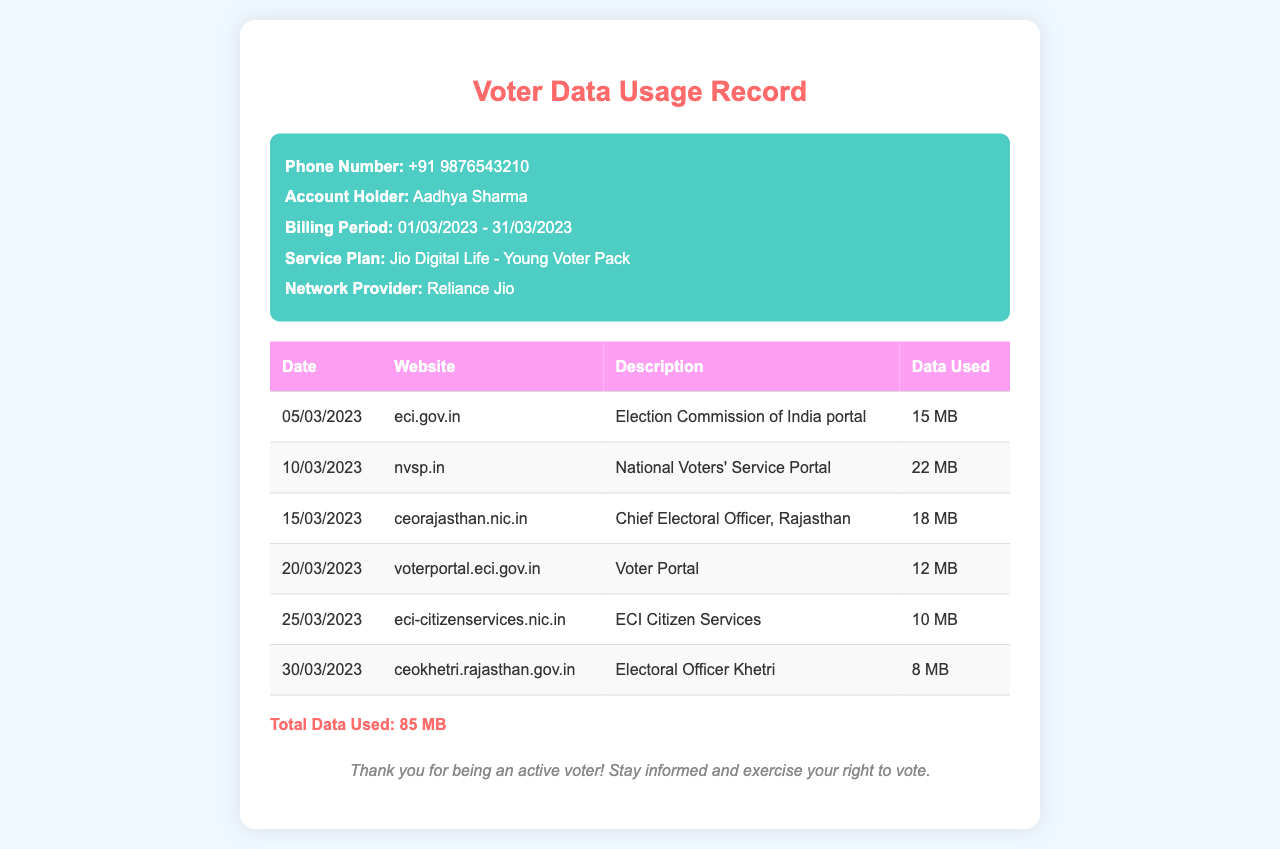what is the phone number listed? The phone number is provided in the header section of the document as a point of reference for the account holder.
Answer: +91 9876543210 what is the total data used during the billing period? The total data used is calculated from the individual data usage provided for each website in the table.
Answer: 85 MB what is the billing period for this record? The billing period indicates the timeframe during which the recorded data usage was measured.
Answer: 01/03/2023 - 31/03/2023 how many megabytes were used on the National Voters' Service Portal? This is found in the corresponding row for the National Voters' Service Portal in the table.
Answer: 22 MB which website had the lowest data usage? The question examines the data usage across all listed websites to find the minimum amount used.
Answer: ceokhetri.rajasthan.gov.in who is the account holder? This is specified in the header section of the document, identifying the individual associated with the phone number.
Answer: Aadhya Sharma what is the service plan mentioned in the document? The service plan details the specific offerings and features available for the account holder as stated in the document.
Answer: Jio Digital Life - Young Voter Pack which date had the highest data usage? Analyzing the data usage, you can identify the date where the maximum megabytes were consumed.
Answer: 10/03/2023 what is the description of the website eci.gov.in? The description provides clarity on the purpose of the website as mentioned in the table.
Answer: Election Commission of India portal 